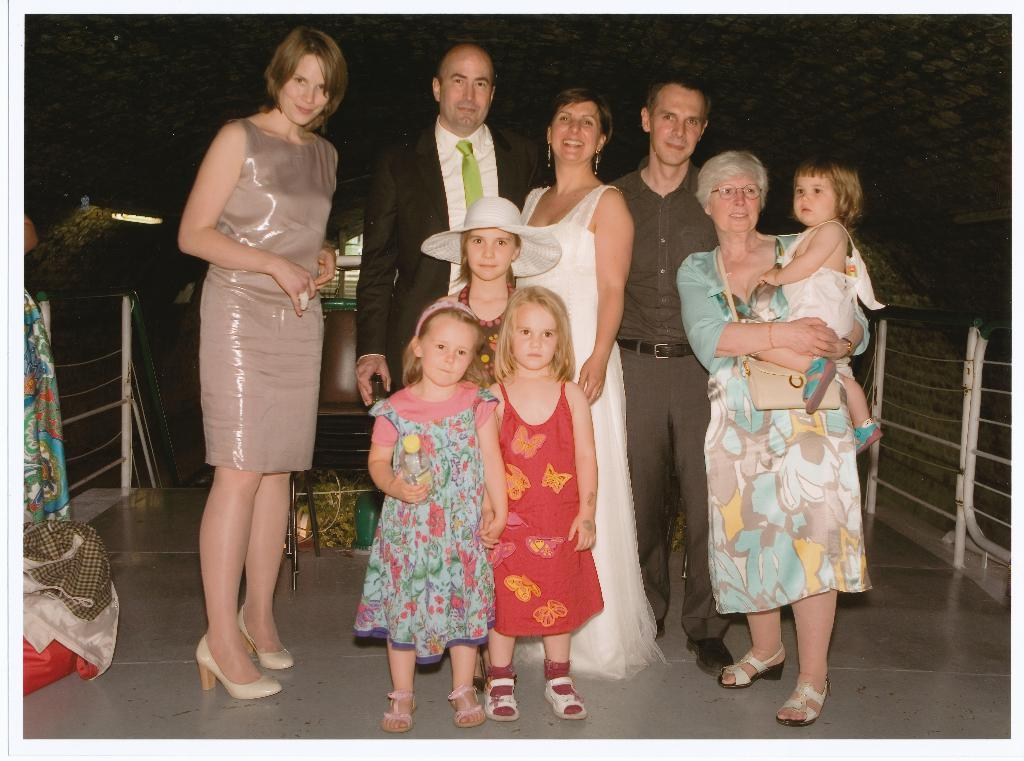What is the main subject of the image? The main subject of the image is a group of people standing. Can you describe any objects in the image? Yes, there is a chair and cloths in the image. Are there any light sources visible in the image? Yes, there are lights in the image. How would you describe the background of the image? The background of the image is dark. What type of rod can be seen in the image? There is no rod present in the image. What is the condition of the people in the image? The image does not provide information about the condition of the people, only their presence and position. 